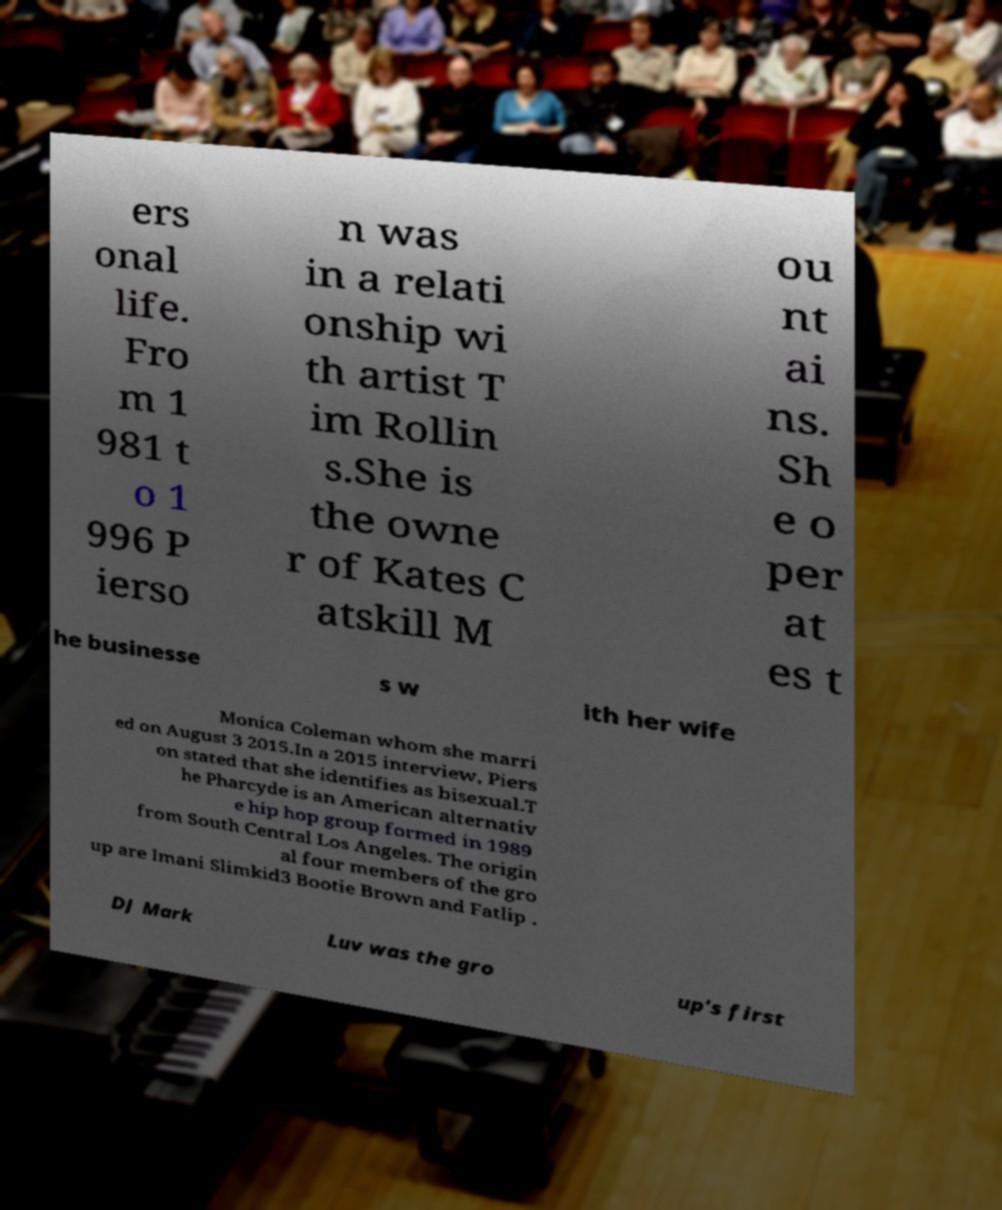Could you assist in decoding the text presented in this image and type it out clearly? ers onal life. Fro m 1 981 t o 1 996 P ierso n was in a relati onship wi th artist T im Rollin s.She is the owne r of Kates C atskill M ou nt ai ns. Sh e o per at es t he businesse s w ith her wife Monica Coleman whom she marri ed on August 3 2015.In a 2015 interview, Piers on stated that she identifies as bisexual.T he Pharcyde is an American alternativ e hip hop group formed in 1989 from South Central Los Angeles. The origin al four members of the gro up are Imani Slimkid3 Bootie Brown and Fatlip . DJ Mark Luv was the gro up's first 